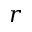Convert formula to latex. <formula><loc_0><loc_0><loc_500><loc_500>r</formula> 